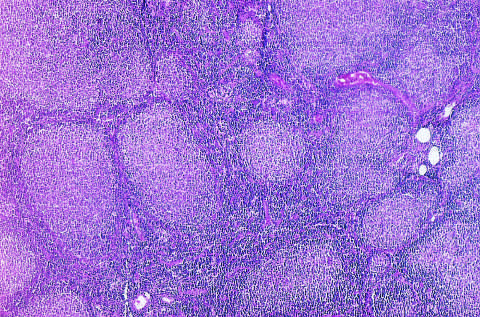what are present throughout?
Answer the question using a single word or phrase. Nodular aggregates of lymphoma cells 